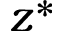<formula> <loc_0><loc_0><loc_500><loc_500>z ^ { * }</formula> 